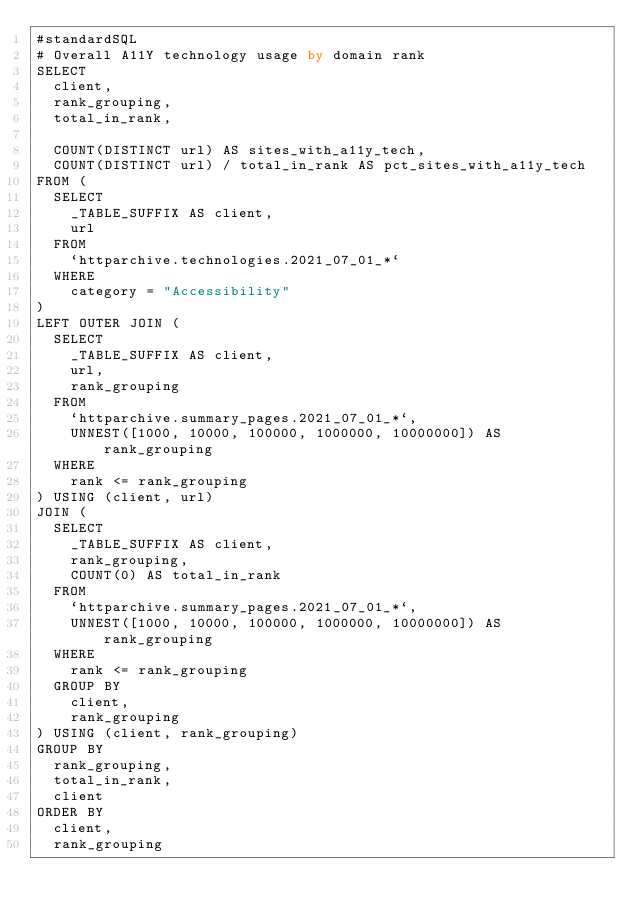Convert code to text. <code><loc_0><loc_0><loc_500><loc_500><_SQL_>#standardSQL
# Overall A11Y technology usage by domain rank
SELECT
  client,
  rank_grouping,
  total_in_rank,

  COUNT(DISTINCT url) AS sites_with_a11y_tech,
  COUNT(DISTINCT url) / total_in_rank AS pct_sites_with_a11y_tech
FROM (
  SELECT
    _TABLE_SUFFIX AS client,
    url
  FROM
    `httparchive.technologies.2021_07_01_*`
  WHERE
    category = "Accessibility"
)
LEFT OUTER JOIN (
  SELECT
    _TABLE_SUFFIX AS client,
    url,
    rank_grouping
  FROM
    `httparchive.summary_pages.2021_07_01_*`,
    UNNEST([1000, 10000, 100000, 1000000, 10000000]) AS rank_grouping
  WHERE
    rank <= rank_grouping
) USING (client, url)
JOIN (
  SELECT
    _TABLE_SUFFIX AS client,
    rank_grouping,
    COUNT(0) AS total_in_rank
  FROM
    `httparchive.summary_pages.2021_07_01_*`,
    UNNEST([1000, 10000, 100000, 1000000, 10000000]) AS rank_grouping
  WHERE
    rank <= rank_grouping
  GROUP BY
    client,
    rank_grouping
) USING (client, rank_grouping)
GROUP BY
  rank_grouping,
  total_in_rank,
  client
ORDER BY
  client,
  rank_grouping
</code> 